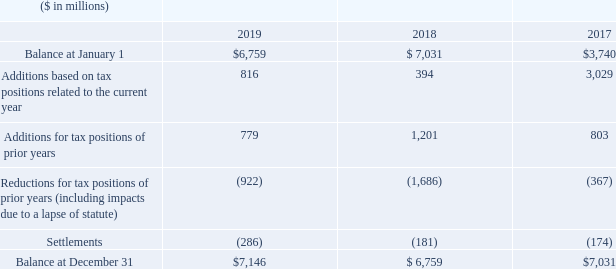The amount of unrecognized tax benefits at December 31, 2019 increased by $387 million in 2019 to $7,146 million. A reconciliation of the beginning and ending amount of unrecognized tax benefits was as follows:
The additions to unrecognized tax benefits related to the current and prior years were primarily attributable to U.S. federal and state tax matters, as well as non-U.S. tax matters, including transfer pricing, credits and incentives. The settlements and reductions to unrecognized tax benefits for tax positions of prior years were primarily attributable to U.S. federal and state tax matters, non-U.S. audits and impacts due to lapse of statute of limitations.
The unrecognized tax benefits at December 31, 2019 of $7,146 million can be reduced by $584 million associated with timing adjustments, U.S. tax credits, potential transfer pricing adjustments and state income taxes. The net amount of $6,562 million, if recognized, would favorably affect the company’s effective tax rate. The net amounts at December 31, 2018 and 2017 were $6,041 million and $6,064 million, respectively.
How much amount did the unrecognized tax benefits increased in 2019? $387 million. What attributed to settlements and reductions to unrecognized tax benefits? The settlements and reductions to unrecognized tax benefits for tax positions of prior years were primarily attributable to u.s. federal and state tax matters, non-u.s. audits and impacts due to lapse of statute of limitations. In December 2019, how much reduction was associated to timing adjustments, U.S. tax credits, potential transfer pricing adjustments and state income taxes. $584 million. What is the average of Balance at January 1?
Answer scale should be: million. (6,759+7,031+3,740) / 3
Answer: 5843.33. What is the average of Balance at December 31?
Answer scale should be: million. (7,146+6,759+7,031) / 3
Answer: 6978.67. What is the average of Settlements for the period 2018-19?
Answer scale should be: million. (-286+(-181)) / 2
Answer: -233.5. 